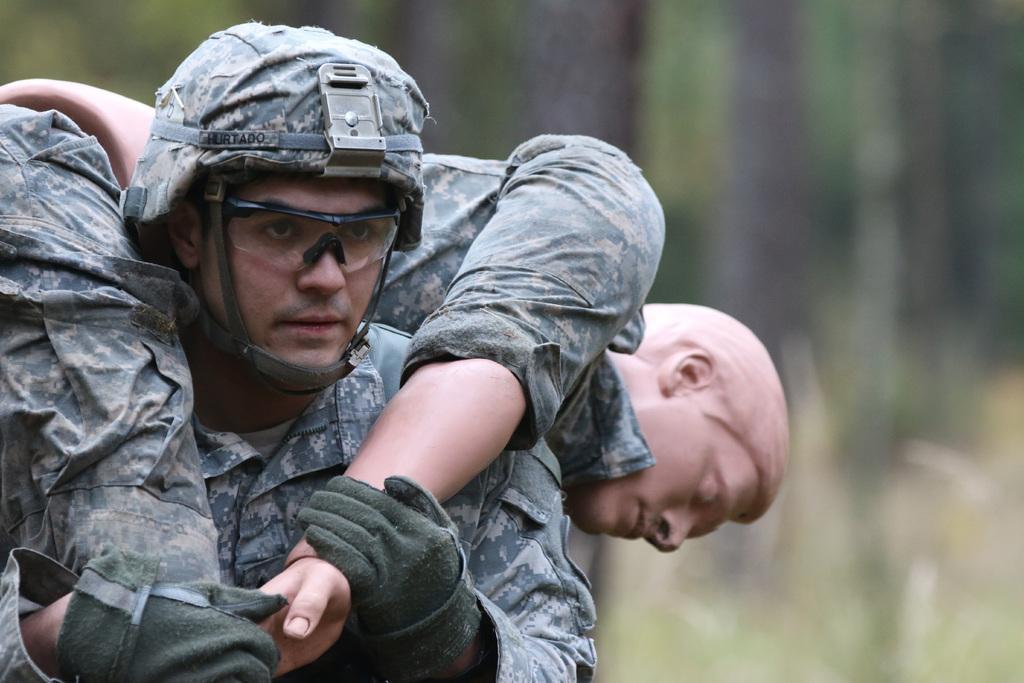Could you give a brief overview of what you see in this image? In this picture we can see two people, one person is wearing a goggles, gloves and in the background we can see it is blurry. 